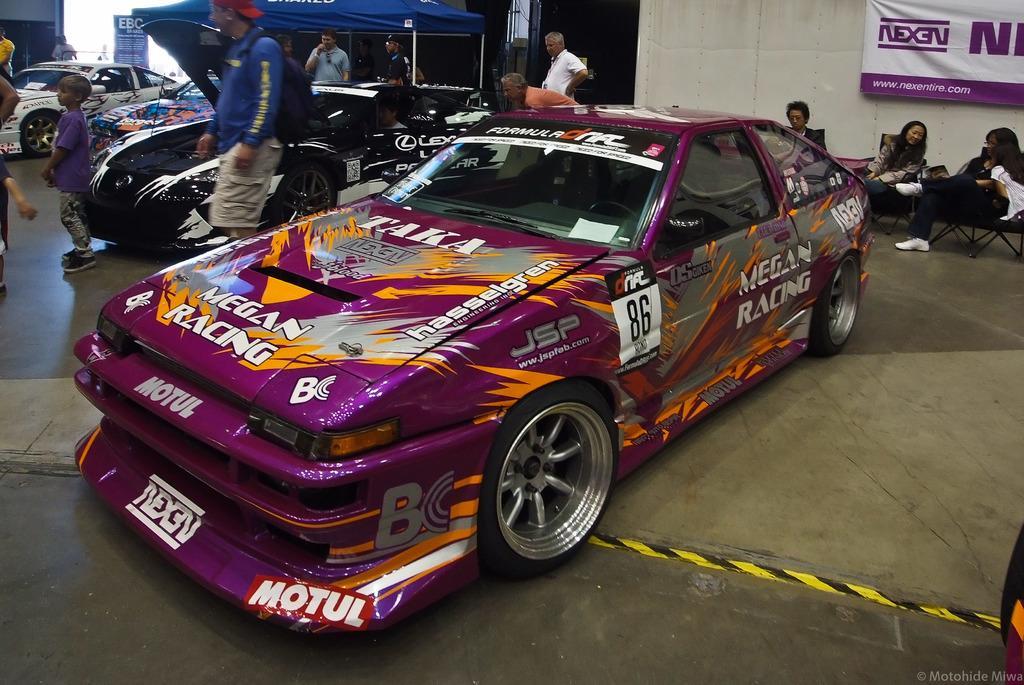Could you give a brief overview of what you see in this image? This is the picture of a place where we have some cars and around there are some people and a poster to the wall. 